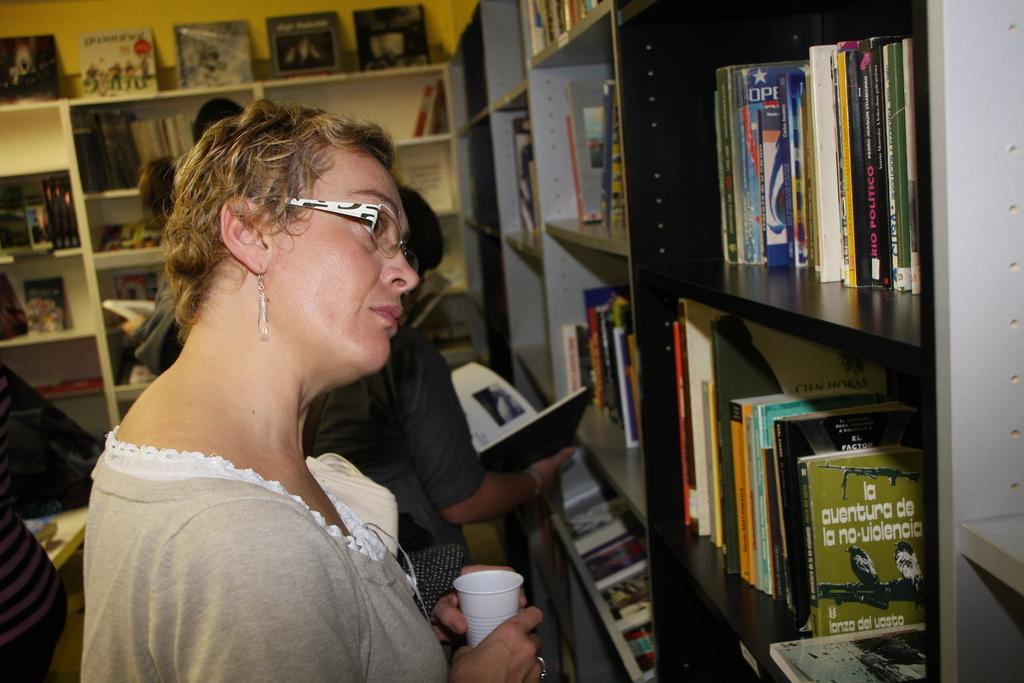<image>
Present a compact description of the photo's key features. A woman tilts her head as she looks at books lined up on shelves including one with a title written in Spanish about an adverture without violence. 